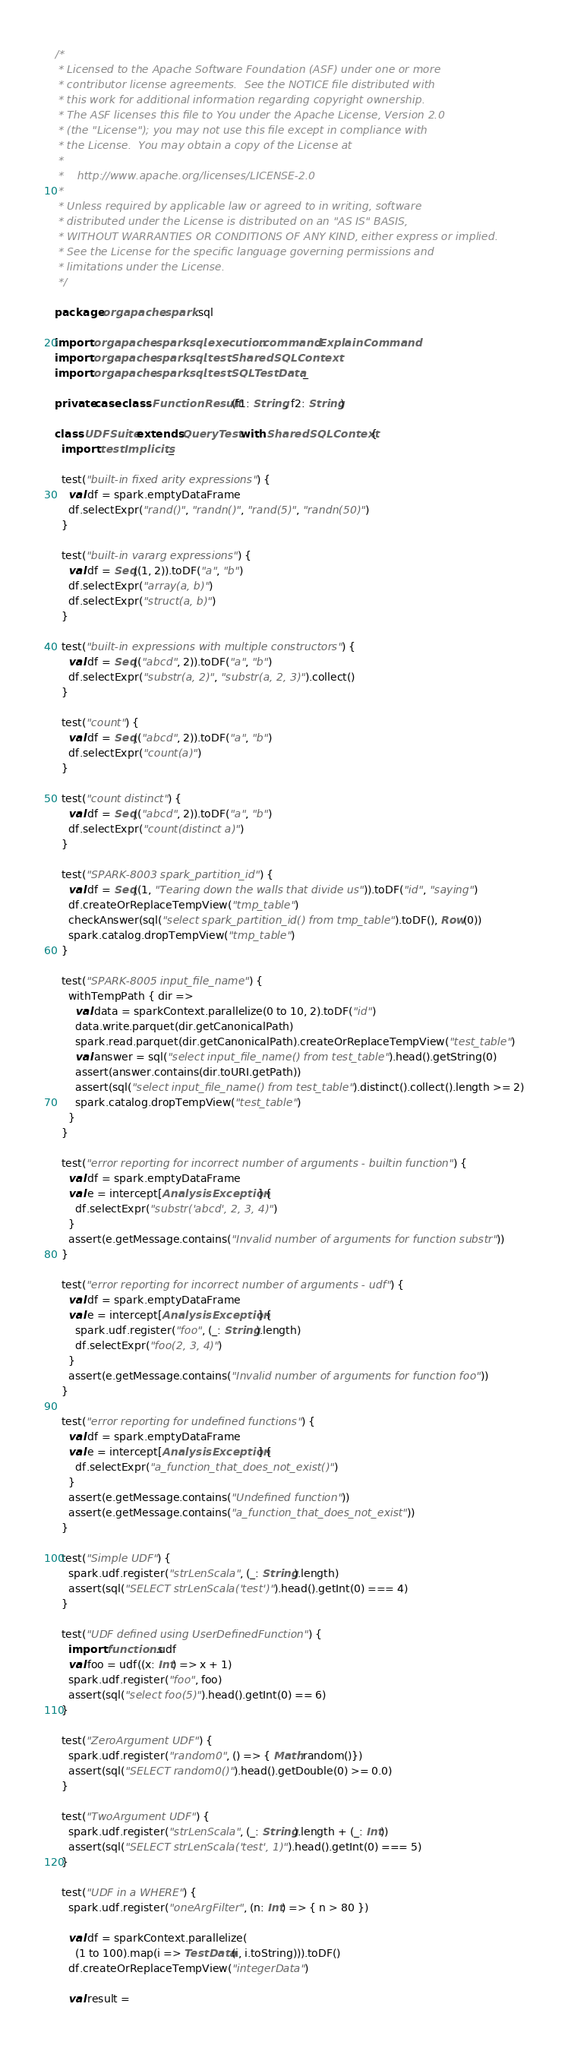<code> <loc_0><loc_0><loc_500><loc_500><_Scala_>/*
 * Licensed to the Apache Software Foundation (ASF) under one or more
 * contributor license agreements.  See the NOTICE file distributed with
 * this work for additional information regarding copyright ownership.
 * The ASF licenses this file to You under the Apache License, Version 2.0
 * (the "License"); you may not use this file except in compliance with
 * the License.  You may obtain a copy of the License at
 *
 *    http://www.apache.org/licenses/LICENSE-2.0
 *
 * Unless required by applicable law or agreed to in writing, software
 * distributed under the License is distributed on an "AS IS" BASIS,
 * WITHOUT WARRANTIES OR CONDITIONS OF ANY KIND, either express or implied.
 * See the License for the specific language governing permissions and
 * limitations under the License.
 */

package org.apache.spark.sql

import org.apache.spark.sql.execution.command.ExplainCommand
import org.apache.spark.sql.test.SharedSQLContext
import org.apache.spark.sql.test.SQLTestData._

private case class FunctionResult(f1: String, f2: String)

class UDFSuite extends QueryTest with SharedSQLContext {
  import testImplicits._

  test("built-in fixed arity expressions") {
    val df = spark.emptyDataFrame
    df.selectExpr("rand()", "randn()", "rand(5)", "randn(50)")
  }

  test("built-in vararg expressions") {
    val df = Seq((1, 2)).toDF("a", "b")
    df.selectExpr("array(a, b)")
    df.selectExpr("struct(a, b)")
  }

  test("built-in expressions with multiple constructors") {
    val df = Seq(("abcd", 2)).toDF("a", "b")
    df.selectExpr("substr(a, 2)", "substr(a, 2, 3)").collect()
  }

  test("count") {
    val df = Seq(("abcd", 2)).toDF("a", "b")
    df.selectExpr("count(a)")
  }

  test("count distinct") {
    val df = Seq(("abcd", 2)).toDF("a", "b")
    df.selectExpr("count(distinct a)")
  }

  test("SPARK-8003 spark_partition_id") {
    val df = Seq((1, "Tearing down the walls that divide us")).toDF("id", "saying")
    df.createOrReplaceTempView("tmp_table")
    checkAnswer(sql("select spark_partition_id() from tmp_table").toDF(), Row(0))
    spark.catalog.dropTempView("tmp_table")
  }

  test("SPARK-8005 input_file_name") {
    withTempPath { dir =>
      val data = sparkContext.parallelize(0 to 10, 2).toDF("id")
      data.write.parquet(dir.getCanonicalPath)
      spark.read.parquet(dir.getCanonicalPath).createOrReplaceTempView("test_table")
      val answer = sql("select input_file_name() from test_table").head().getString(0)
      assert(answer.contains(dir.toURI.getPath))
      assert(sql("select input_file_name() from test_table").distinct().collect().length >= 2)
      spark.catalog.dropTempView("test_table")
    }
  }

  test("error reporting for incorrect number of arguments - builtin function") {
    val df = spark.emptyDataFrame
    val e = intercept[AnalysisException] {
      df.selectExpr("substr('abcd', 2, 3, 4)")
    }
    assert(e.getMessage.contains("Invalid number of arguments for function substr"))
  }

  test("error reporting for incorrect number of arguments - udf") {
    val df = spark.emptyDataFrame
    val e = intercept[AnalysisException] {
      spark.udf.register("foo", (_: String).length)
      df.selectExpr("foo(2, 3, 4)")
    }
    assert(e.getMessage.contains("Invalid number of arguments for function foo"))
  }

  test("error reporting for undefined functions") {
    val df = spark.emptyDataFrame
    val e = intercept[AnalysisException] {
      df.selectExpr("a_function_that_does_not_exist()")
    }
    assert(e.getMessage.contains("Undefined function"))
    assert(e.getMessage.contains("a_function_that_does_not_exist"))
  }

  test("Simple UDF") {
    spark.udf.register("strLenScala", (_: String).length)
    assert(sql("SELECT strLenScala('test')").head().getInt(0) === 4)
  }

  test("UDF defined using UserDefinedFunction") {
    import functions.udf
    val foo = udf((x: Int) => x + 1)
    spark.udf.register("foo", foo)
    assert(sql("select foo(5)").head().getInt(0) == 6)
  }

  test("ZeroArgument UDF") {
    spark.udf.register("random0", () => { Math.random()})
    assert(sql("SELECT random0()").head().getDouble(0) >= 0.0)
  }

  test("TwoArgument UDF") {
    spark.udf.register("strLenScala", (_: String).length + (_: Int))
    assert(sql("SELECT strLenScala('test', 1)").head().getInt(0) === 5)
  }

  test("UDF in a WHERE") {
    spark.udf.register("oneArgFilter", (n: Int) => { n > 80 })

    val df = sparkContext.parallelize(
      (1 to 100).map(i => TestData(i, i.toString))).toDF()
    df.createOrReplaceTempView("integerData")

    val result =</code> 